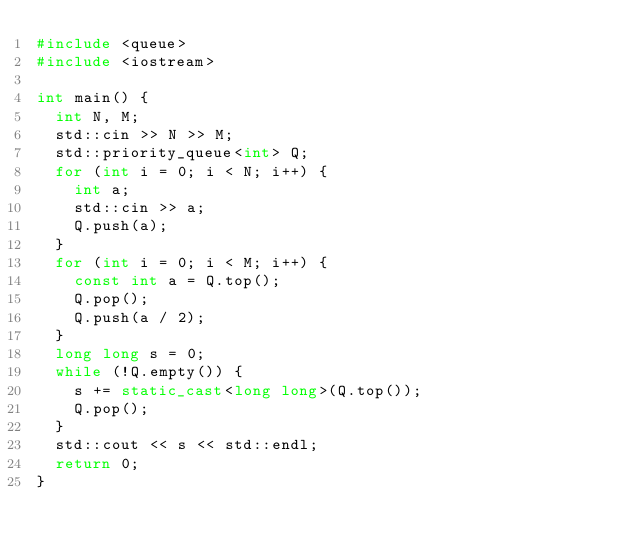<code> <loc_0><loc_0><loc_500><loc_500><_C++_>#include <queue>
#include <iostream>

int main() {
  int N, M;
  std::cin >> N >> M;
  std::priority_queue<int> Q;
  for (int i = 0; i < N; i++) {
    int a;
    std::cin >> a;
    Q.push(a);
  }
  for (int i = 0; i < M; i++) {
    const int a = Q.top();
    Q.pop();
    Q.push(a / 2);
  }
  long long s = 0;
  while (!Q.empty()) {
    s += static_cast<long long>(Q.top());
    Q.pop();
  }
  std::cout << s << std::endl;
  return 0;
}
</code> 